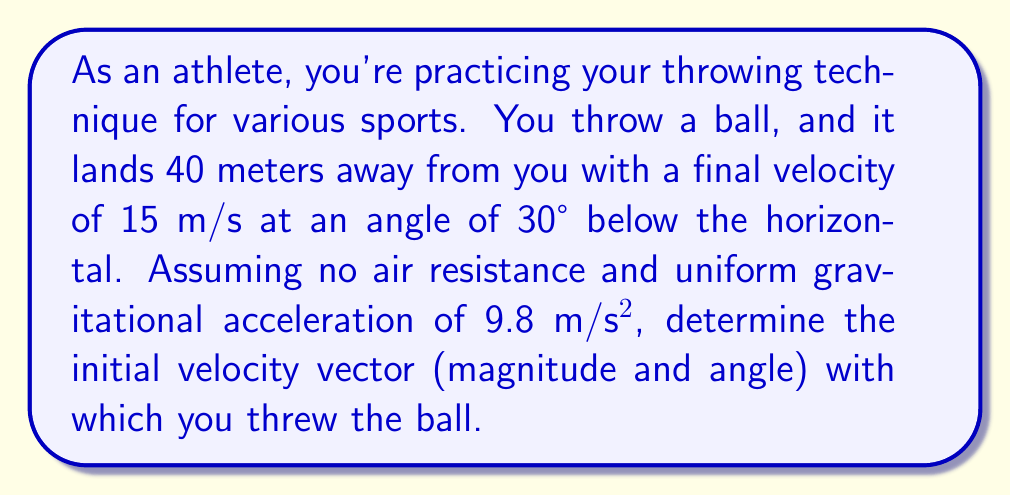Could you help me with this problem? Let's approach this step-by-step:

1) First, we need to set up our coordinate system. Let's choose the origin as the initial position of the ball, with positive x-direction in the direction of throw, and positive y-direction upwards.

2) We know the final position $(x_f, y_f)$ = $(40, 0)$ (since it lands on the ground).

3) The final velocity components are:
   $v_{fx} = 15 \cos(-30°) = 12.99$ m/s
   $v_{fy} = 15 \sin(-30°) = -7.5$ m/s

4) We can use the equations of motion for projectile motion:

   $x = x_0 + v_{0x}t$
   $y = y_0 + v_{0y}t - \frac{1}{2}gt^2$
   $v_x = v_{0x}$
   $v_y = v_{0y} - gt$

   Where $(x_0, y_0) = (0, 0)$, $g = 9.8$ m/s², and $t$ is the time of flight.

5) From the x-equation:
   $40 = v_{0x}t$
   $t = \frac{40}{v_{0x}}$

6) Substituting this into the y-equation:
   $0 = v_{0y}\frac{40}{v_{0x}} - \frac{1}{2}g(\frac{40}{v_{0x}})^2$

7) Rearranging:
   $v_{0y} = \frac{20g}{v_{0x}}$

8) Now, we can use the final velocity equations:
   $12.99 = v_{0x}$
   $-7.5 = v_{0y} - g\frac{40}{v_{0x}}$

9) Substituting $v_{0x} = 12.99$ into the equation from step 7:
   $v_{0y} = \frac{20(9.8)}{12.99} = 15.09$ m/s

10) We can now calculate the initial velocity magnitude:
    $v_0 = \sqrt{v_{0x}^2 + v_{0y}^2} = \sqrt{12.99^2 + 15.09^2} = 19.9$ m/s

11) And the angle:
    $\theta = \tan^{-1}(\frac{v_{0y}}{v_{0x}}) = \tan^{-1}(\frac{15.09}{12.99}) = 49.3°$
Answer: $v_0 = 19.9$ m/s, $\theta = 49.3°$ above horizontal 